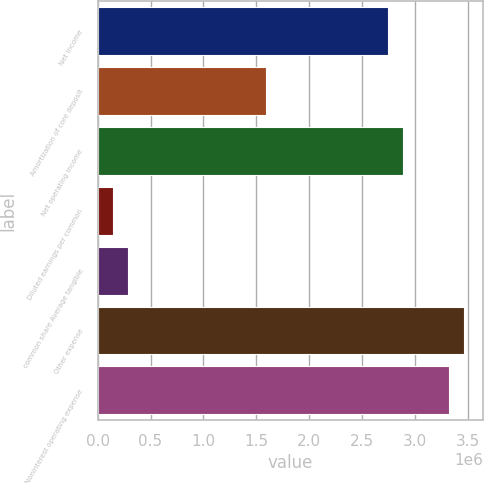Convert chart. <chart><loc_0><loc_0><loc_500><loc_500><bar_chart><fcel>Net income<fcel>Amortization of core deposit<fcel>Net operating income<fcel>Diluted earnings per common<fcel>common share Average tangible<fcel>Other expense<fcel>Noninterest operating expense<nl><fcel>2.74211e+06<fcel>1.58754e+06<fcel>2.88643e+06<fcel>144321<fcel>288643<fcel>3.46371e+06<fcel>3.31939e+06<nl></chart> 